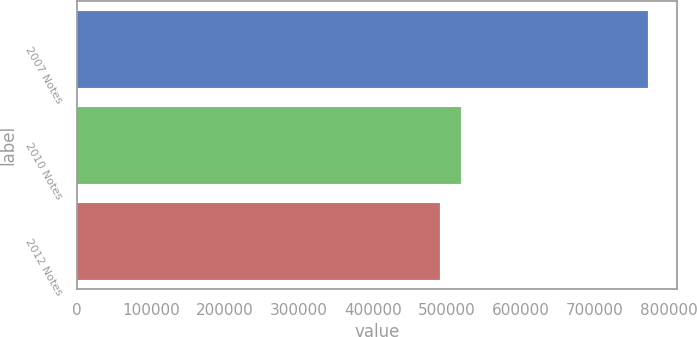Convert chart to OTSL. <chart><loc_0><loc_0><loc_500><loc_500><bar_chart><fcel>2007 Notes<fcel>2010 Notes<fcel>2012 Notes<nl><fcel>771600<fcel>518790<fcel>490700<nl></chart> 